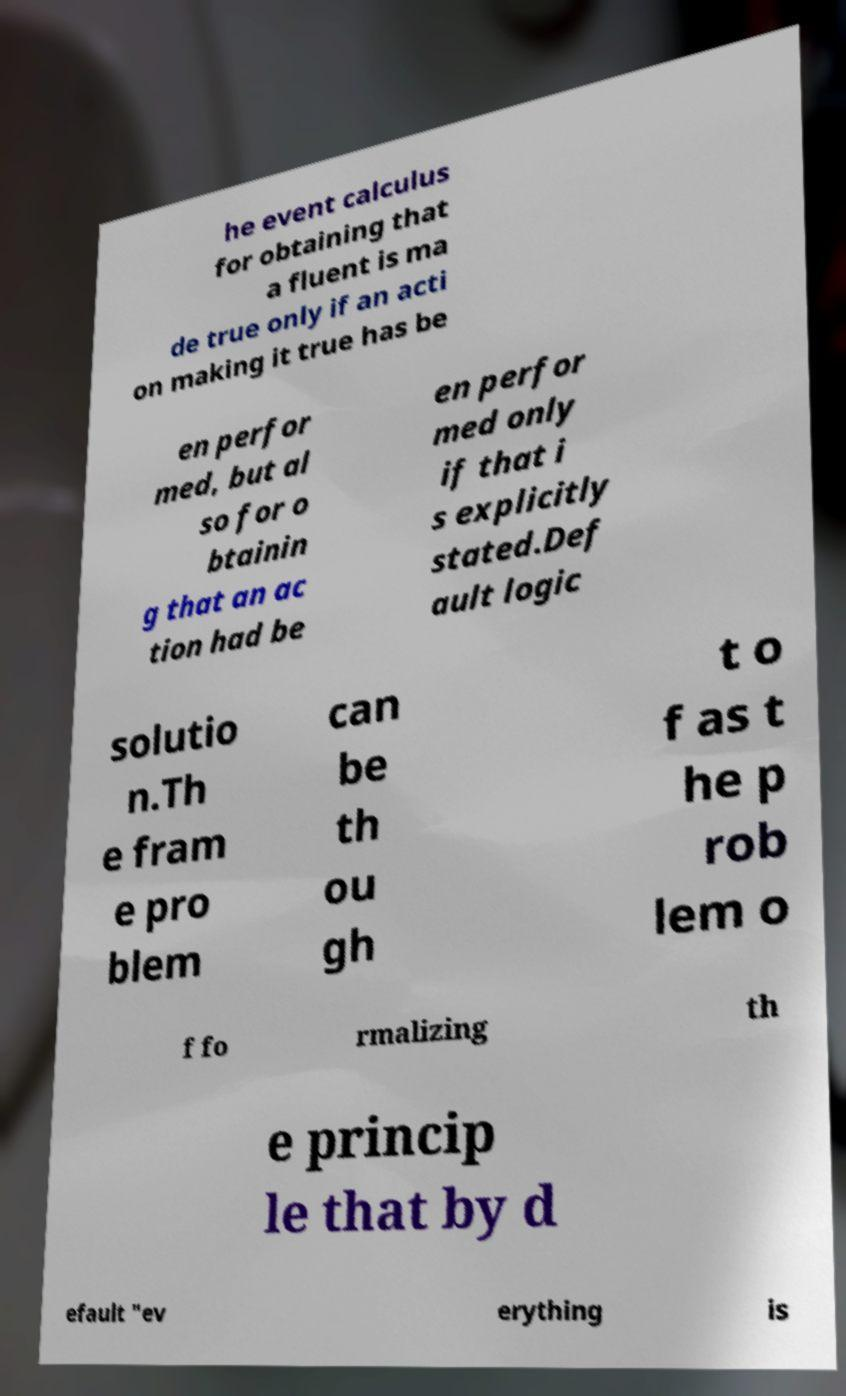Could you extract and type out the text from this image? he event calculus for obtaining that a fluent is ma de true only if an acti on making it true has be en perfor med, but al so for o btainin g that an ac tion had be en perfor med only if that i s explicitly stated.Def ault logic solutio n.Th e fram e pro blem can be th ou gh t o f as t he p rob lem o f fo rmalizing th e princip le that by d efault "ev erything is 